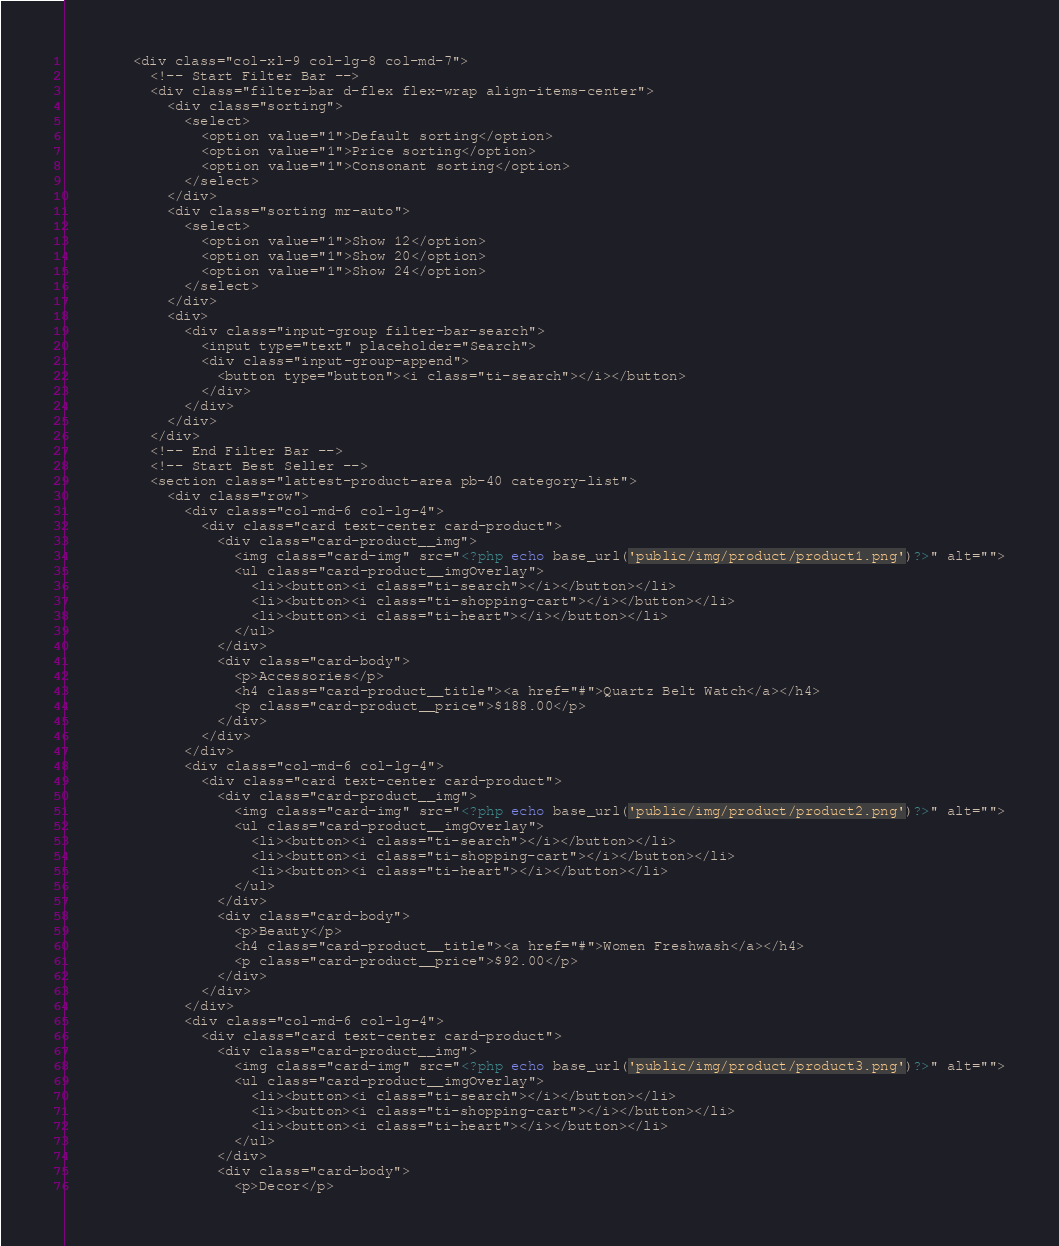<code> <loc_0><loc_0><loc_500><loc_500><_PHP_>
        <div class="col-xl-9 col-lg-8 col-md-7">
          <!-- Start Filter Bar -->
          <div class="filter-bar d-flex flex-wrap align-items-center">
            <div class="sorting">
              <select>
                <option value="1">Default sorting</option>
                <option value="1">Price sorting</option>
                <option value="1">Consonant sorting</option>
              </select>
            </div>
            <div class="sorting mr-auto">
              <select>
                <option value="1">Show 12</option>
                <option value="1">Show 20</option>
                <option value="1">Show 24</option>
              </select>
            </div>
            <div>
              <div class="input-group filter-bar-search">
                <input type="text" placeholder="Search">
                <div class="input-group-append">
                  <button type="button"><i class="ti-search"></i></button>
                </div>
              </div>
            </div>
          </div>
          <!-- End Filter Bar -->
          <!-- Start Best Seller -->
          <section class="lattest-product-area pb-40 category-list">
            <div class="row">
              <div class="col-md-6 col-lg-4">
                <div class="card text-center card-product">
                  <div class="card-product__img">
                    <img class="card-img" src="<?php echo base_url('public/img/product/product1.png')?>" alt="">
                    <ul class="card-product__imgOverlay">
                      <li><button><i class="ti-search"></i></button></li>
                      <li><button><i class="ti-shopping-cart"></i></button></li>
                      <li><button><i class="ti-heart"></i></button></li>
                    </ul>
                  </div>
                  <div class="card-body">
                    <p>Accessories</p>
                    <h4 class="card-product__title"><a href="#">Quartz Belt Watch</a></h4>
                    <p class="card-product__price">$188.00</p>
                  </div>
                </div>
              </div>
              <div class="col-md-6 col-lg-4">
                <div class="card text-center card-product">
                  <div class="card-product__img">
                    <img class="card-img" src="<?php echo base_url('public/img/product/product2.png')?>" alt="">
                    <ul class="card-product__imgOverlay">
                      <li><button><i class="ti-search"></i></button></li>
                      <li><button><i class="ti-shopping-cart"></i></button></li>
                      <li><button><i class="ti-heart"></i></button></li>
                    </ul>
                  </div>
                  <div class="card-body">
                    <p>Beauty</p>
                    <h4 class="card-product__title"><a href="#">Women Freshwash</a></h4>
                    <p class="card-product__price">$92.00</p>
                  </div>
                </div>
              </div>
              <div class="col-md-6 col-lg-4">
                <div class="card text-center card-product">
                  <div class="card-product__img">
                    <img class="card-img" src="<?php echo base_url('public/img/product/product3.png')?>" alt="">
                    <ul class="card-product__imgOverlay">
                      <li><button><i class="ti-search"></i></button></li>
                      <li><button><i class="ti-shopping-cart"></i></button></li>
                      <li><button><i class="ti-heart"></i></button></li>
                    </ul>
                  </div>
                  <div class="card-body">
                    <p>Decor</p></code> 